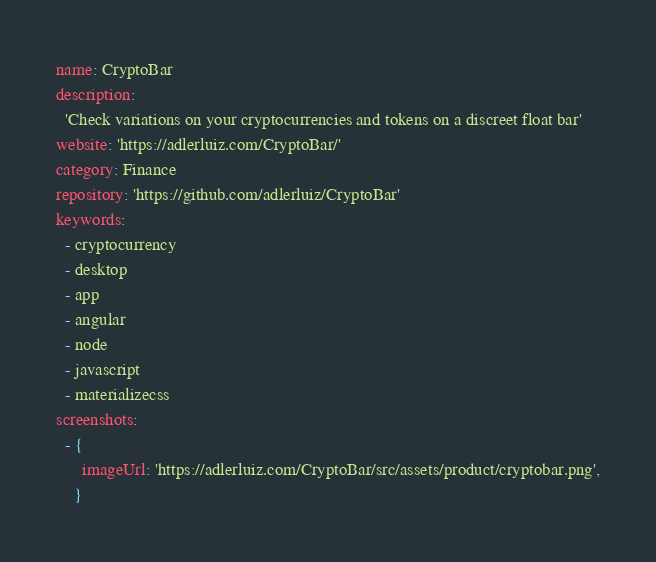Convert code to text. <code><loc_0><loc_0><loc_500><loc_500><_YAML_>name: CryptoBar
description:
  'Check variations on your cryptocurrencies and tokens on a discreet float bar'
website: 'https://adlerluiz.com/CryptoBar/'
category: Finance
repository: 'https://github.com/adlerluiz/CryptoBar'
keywords:
  - cryptocurrency
  - desktop
  - app
  - angular
  - node
  - javascript
  - materializecss
screenshots:
  - {
      imageUrl: 'https://adlerluiz.com/CryptoBar/src/assets/product/cryptobar.png',
    }
</code> 